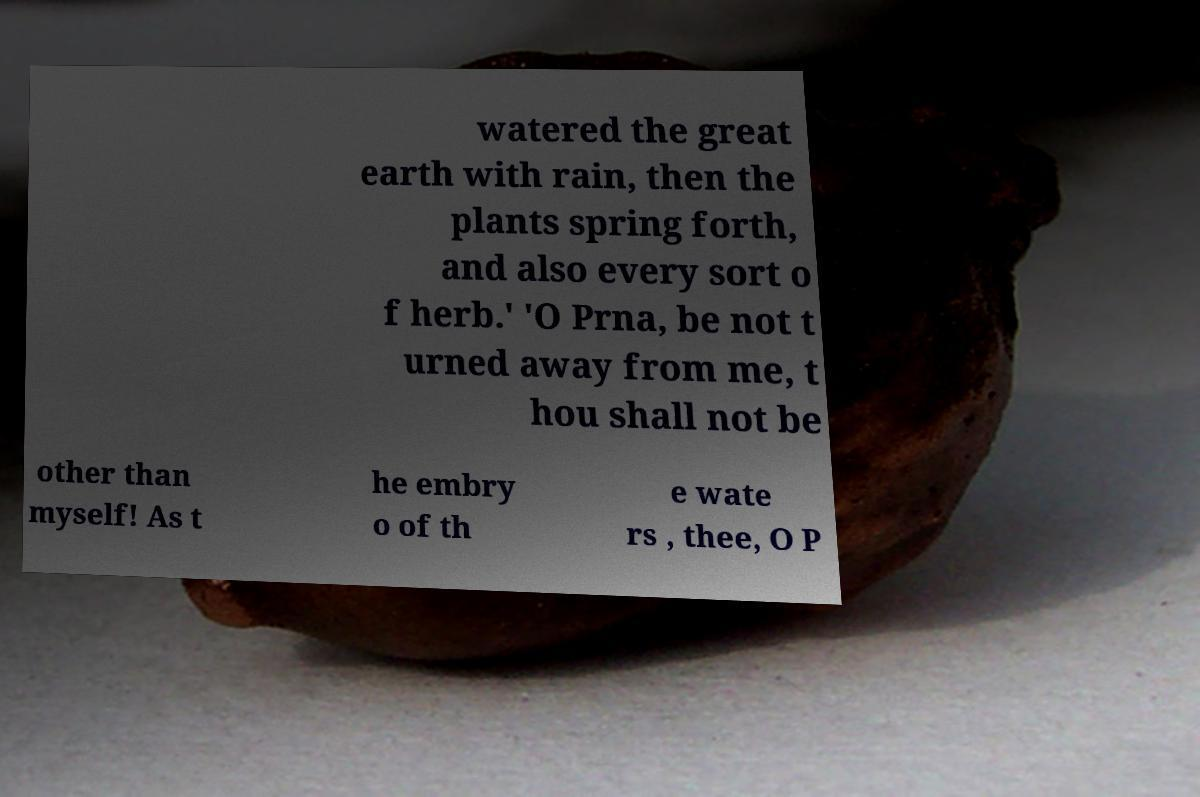I need the written content from this picture converted into text. Can you do that? watered the great earth with rain, then the plants spring forth, and also every sort o f herb.' 'O Prna, be not t urned away from me, t hou shall not be other than myself! As t he embry o of th e wate rs , thee, O P 